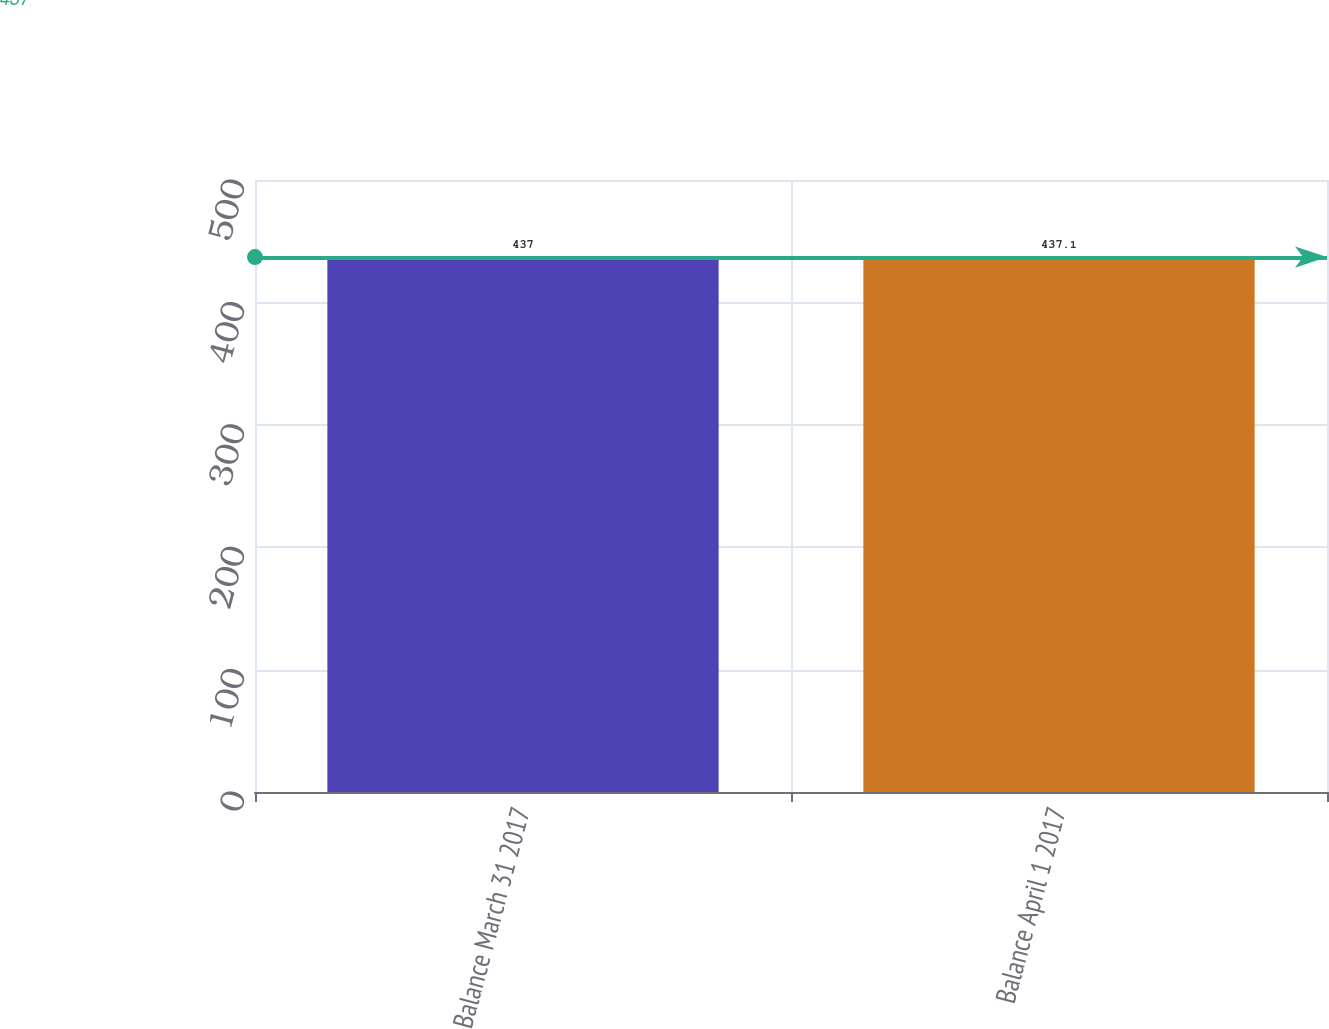<chart> <loc_0><loc_0><loc_500><loc_500><bar_chart><fcel>Balance March 31 2017<fcel>Balance April 1 2017<nl><fcel>437<fcel>437.1<nl></chart> 